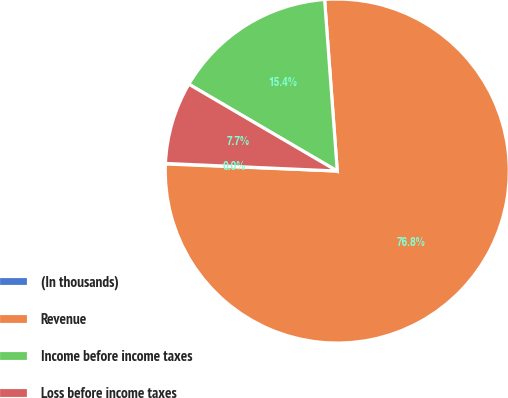Convert chart to OTSL. <chart><loc_0><loc_0><loc_500><loc_500><pie_chart><fcel>(In thousands)<fcel>Revenue<fcel>Income before income taxes<fcel>Loss before income taxes<nl><fcel>0.05%<fcel>76.83%<fcel>15.4%<fcel>7.72%<nl></chart> 